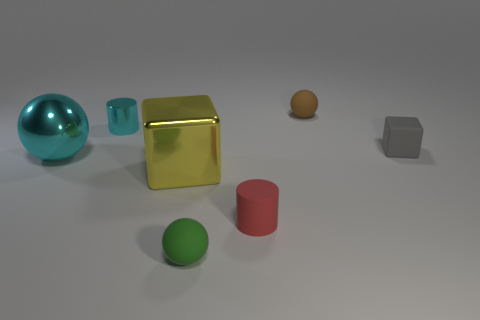How many metallic objects are tiny green things or big things?
Give a very brief answer. 2. What shape is the object that is the same color as the big sphere?
Your answer should be compact. Cylinder. Do the big metallic object that is left of the small metallic object and the small shiny cylinder have the same color?
Your answer should be very brief. Yes. There is a big metallic object to the left of the cylinder behind the big yellow thing; what is its shape?
Offer a very short reply. Sphere. How many objects are tiny matte balls behind the small gray block or small shiny cylinders to the left of the brown thing?
Your answer should be very brief. 2. The gray thing that is the same material as the brown thing is what shape?
Provide a short and direct response. Cube. Are there any other things of the same color as the tiny shiny cylinder?
Your answer should be very brief. Yes. What is the material of the cyan object that is the same shape as the brown object?
Offer a very short reply. Metal. How many other objects are the same size as the cyan cylinder?
Keep it short and to the point. 4. What is the red cylinder made of?
Make the answer very short. Rubber. 